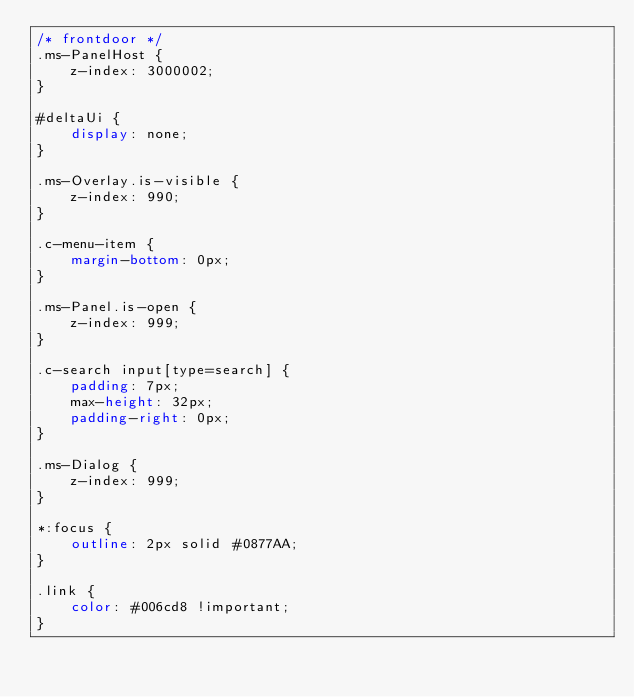<code> <loc_0><loc_0><loc_500><loc_500><_CSS_>/* frontdoor */
.ms-PanelHost {
    z-index: 3000002;
}

#deltaUi {
    display: none;
}

.ms-Overlay.is-visible {
    z-index: 990;
}

.c-menu-item {
    margin-bottom: 0px;
}

.ms-Panel.is-open {
    z-index: 999;
}

.c-search input[type=search] {
    padding: 7px;
    max-height: 32px;
    padding-right: 0px;
}

.ms-Dialog {
    z-index: 999;
}

*:focus {
    outline: 2px solid #0877AA;
}

.link {
    color: #006cd8 !important;
}
</code> 